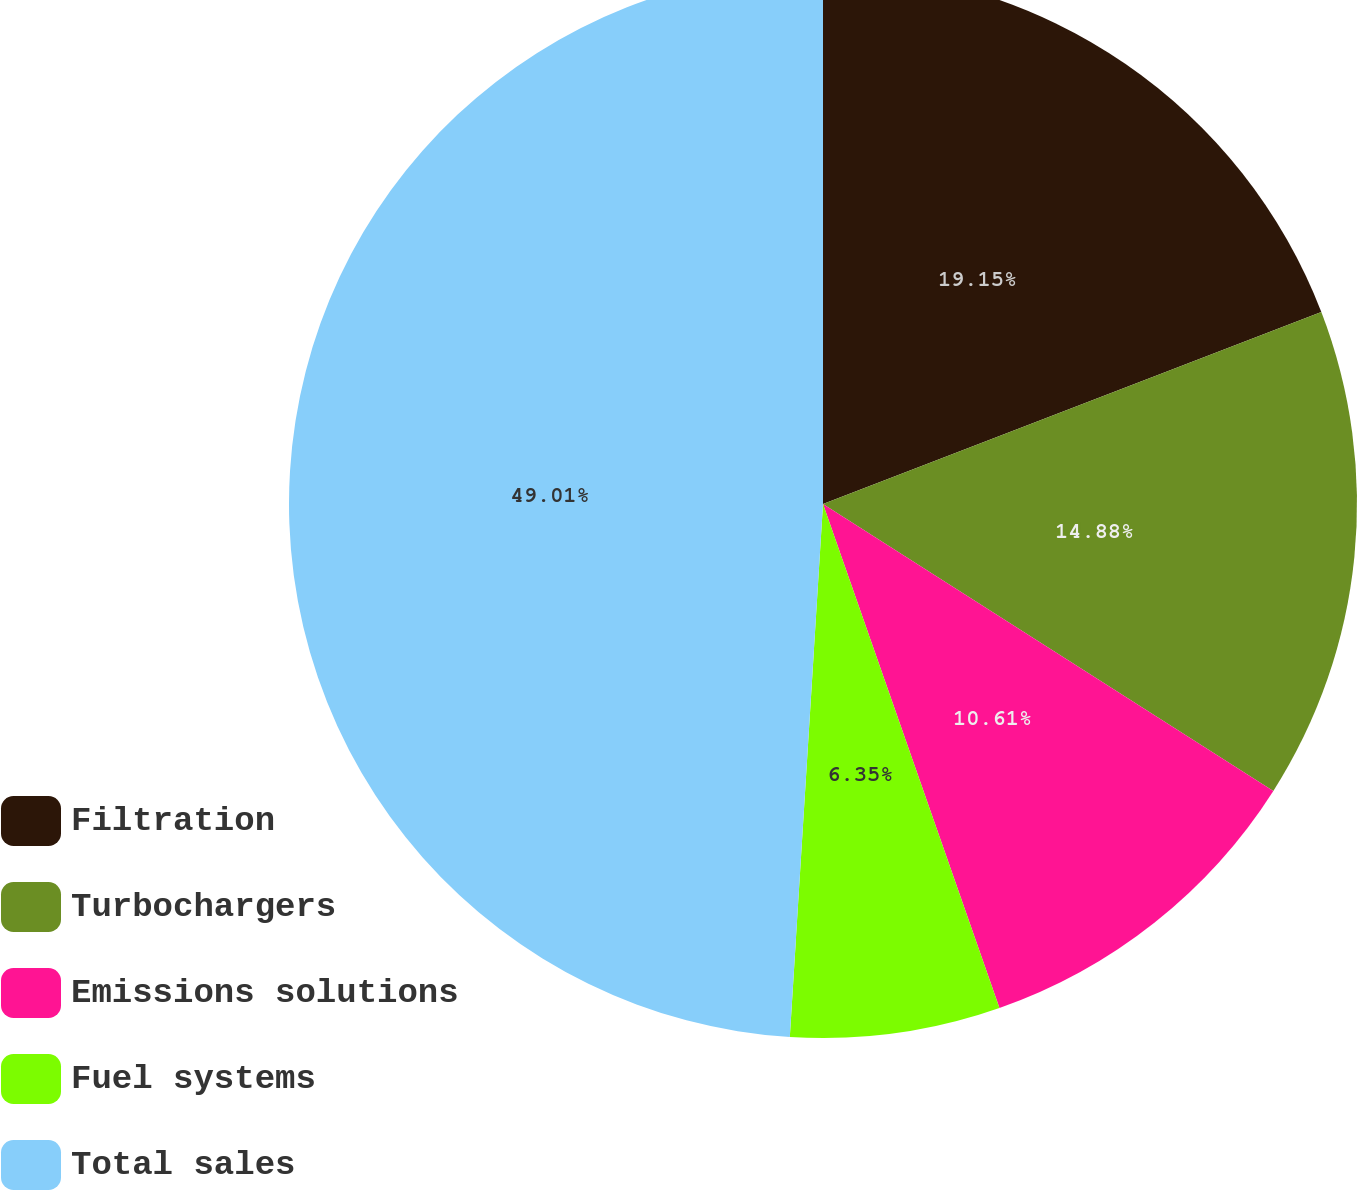<chart> <loc_0><loc_0><loc_500><loc_500><pie_chart><fcel>Filtration<fcel>Turbochargers<fcel>Emissions solutions<fcel>Fuel systems<fcel>Total sales<nl><fcel>19.15%<fcel>14.88%<fcel>10.61%<fcel>6.35%<fcel>49.01%<nl></chart> 